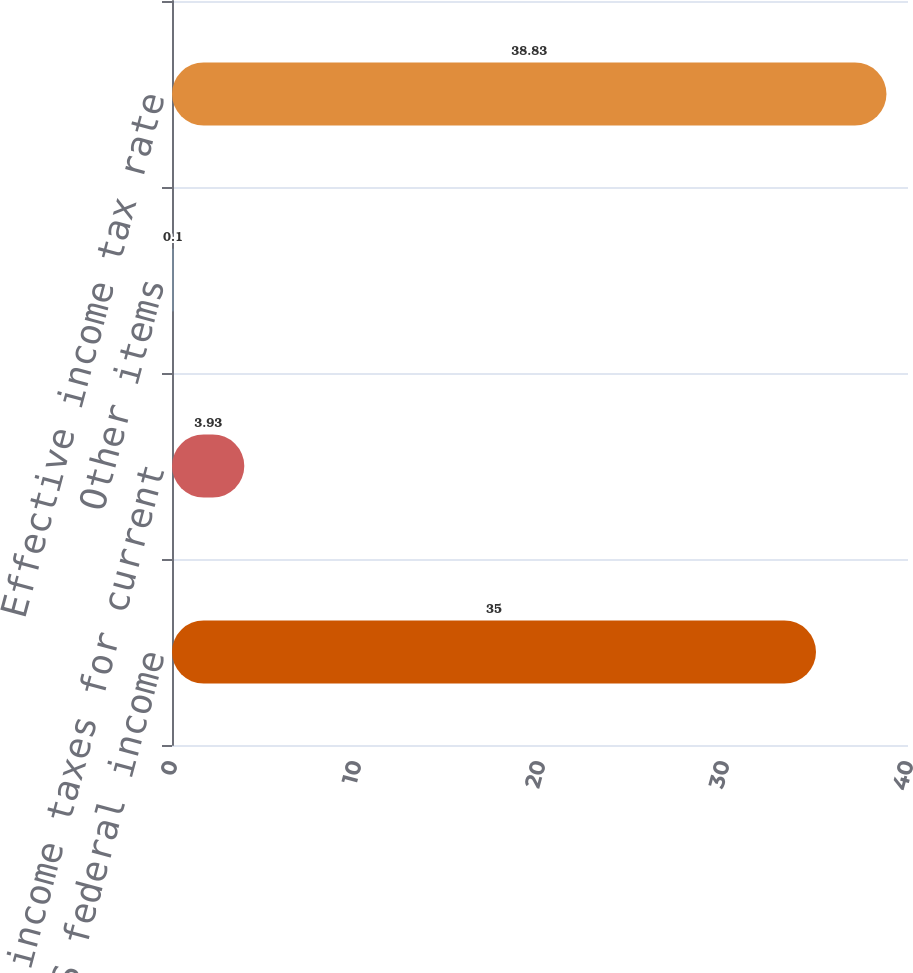Convert chart to OTSL. <chart><loc_0><loc_0><loc_500><loc_500><bar_chart><fcel>Statutory US federal income<fcel>State income taxes for current<fcel>Other items<fcel>Effective income tax rate<nl><fcel>35<fcel>3.93<fcel>0.1<fcel>38.83<nl></chart> 